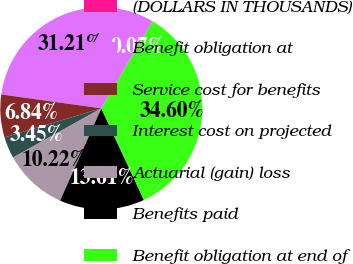<chart> <loc_0><loc_0><loc_500><loc_500><pie_chart><fcel>(DOLLARS IN THOUSANDS)<fcel>Benefit obligation at<fcel>Service cost for benefits<fcel>Interest cost on projected<fcel>Actuarial (gain) loss<fcel>Benefits paid<fcel>Benefit obligation at end of<nl><fcel>0.07%<fcel>31.21%<fcel>6.84%<fcel>3.45%<fcel>10.22%<fcel>13.61%<fcel>34.6%<nl></chart> 